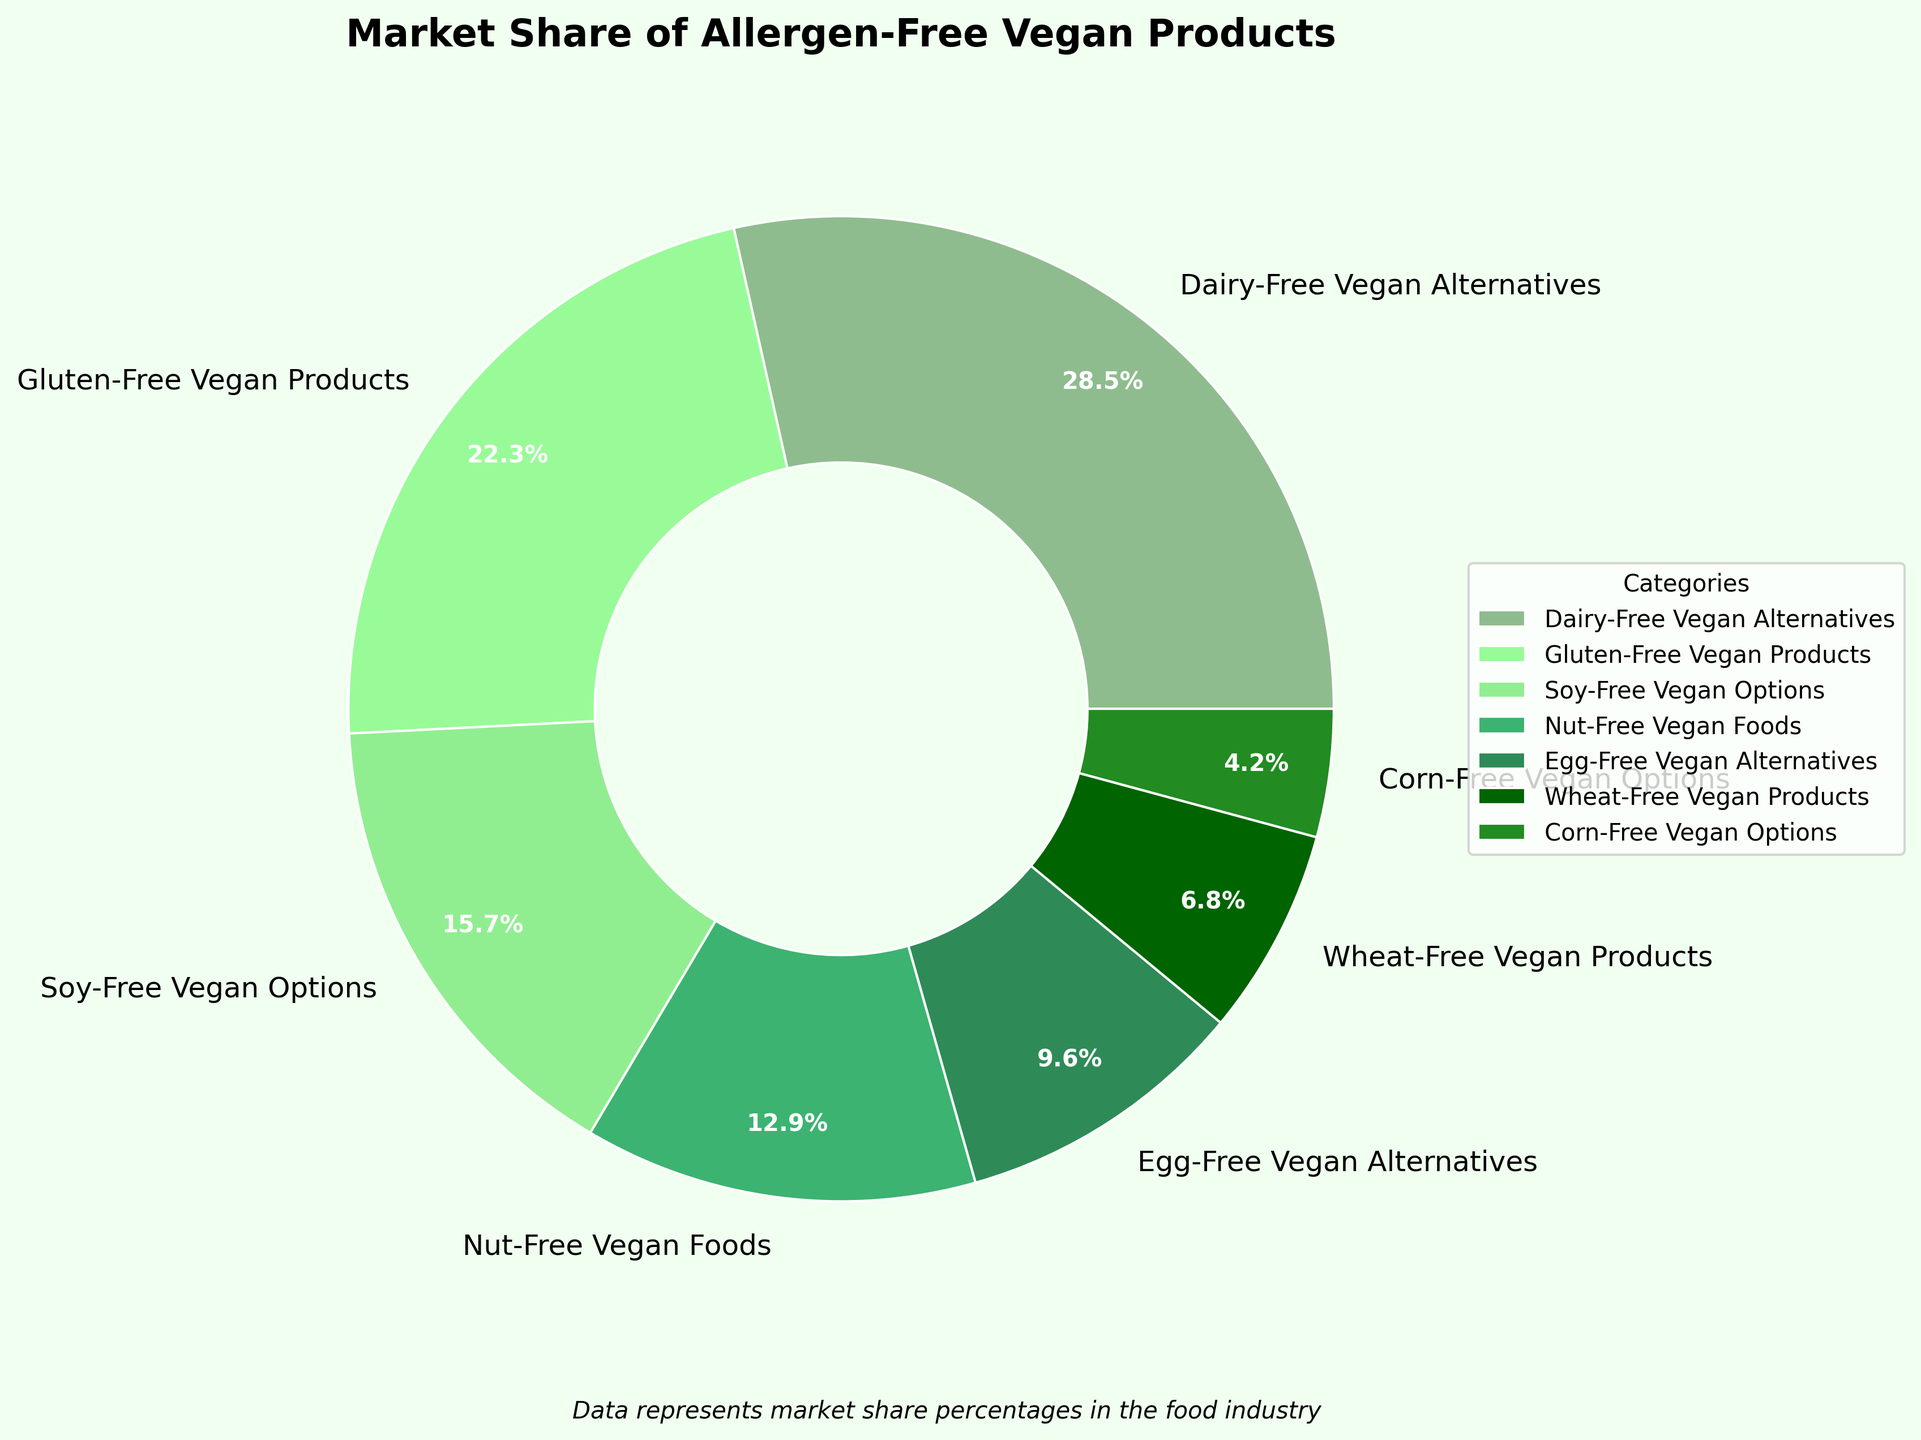Which category has the highest market share? The pie chart shows various categories with their corresponding market shares. The category with the highest percentage is visually identifiable as Dairy-Free Vegan Alternatives.
Answer: Dairy-Free Vegan Alternatives What is the combined market share of Nut-Free Vegan Foods and Egg-Free Vegan Alternatives? To find the combined market share, you need to add the market shares of Nut-Free Vegan Foods (12.9) and Egg-Free Vegan Alternatives (9.6). The sum of 12.9 and 9.6 is 22.5.
Answer: 22.5 Which category has a market share close to 22%? From the pie chart, the category that closely matches 22% is Gluten-Free Vegan Products, which has a market share of 22.3%.
Answer: Gluten-Free Vegan Products How does the market share of Soy-Free Vegan Options compare to that of Wheat-Free Vegan Products? The pie chart indicates that Soy-Free Vegan Options have a market share of 15.7%, whereas Wheat-Free Vegan Products have a smaller share of 6.8%. Therefore, Soy-Free Vegan Options have a higher market share.
Answer: Soy-Free Vegan Options have a higher market share What is the total market share of all categories excluding Dairy-Free Vegan Alternatives? Excluding Dairy-Free Vegan Alternatives, sum the market shares of all other categories: 22.3 (Gluten-Free Vegan Products) + 15.7 (Soy-Free Vegan Options) + 12.9 (Nut-Free Vegan Foods) + 9.6 (Egg-Free Vegan Alternatives) + 6.8 (Wheat-Free Vegan Products) + 4.2 (Corn-Free Vegan Options) = 71.5.
Answer: 71.5 Which category has the smallest market share, and what is its percentage? From the pie chart, Corn-Free Vegan Options has the smallest market share, which is shown as 4.2%.
Answer: Corn-Free Vegan Options, 4.2% By how much does the market share of Dairy-Free Vegan Alternatives exceed that of Nut-Free Vegan Foods? To determine the difference, subtract the market share of Nut-Free Vegan Foods (12.9) from Dairy-Free Vegan Alternatives (28.5). The difference is 28.5 - 12.9 = 15.6.
Answer: 15.6 Are there more categories with a market share greater than 10% or less than 10%? The categories with a market share greater than 10% are Dairy-Free Vegan Alternatives (28.5), Gluten-Free Vegan Products (22.3), Soy-Free Vegan Options (15.7), and Nut-Free Vegan Foods (12.9). Those with less than 10% are Egg-Free Vegan Alternatives (9.6), Wheat-Free Vegan Products (6.8), and Corn-Free Vegan Options (4.2). Thus, there are more categories with a market share greater than 10% (4) compared to those with less than 10% (3).
Answer: More categories have a market share greater than 10% What is the average market share of all categories? To calculate the average, sum the market shares of all categories and divide by the number of categories. (28.5 + 22.3 + 15.7 + 12.9 + 9.6 + 6.8 + 4.2) / 7 = 100 / 7 ≈ 14.29.
Answer: Approximately 14.29 If the market share of Gluten-Free Vegan Products increased by 5%, what would be the new combined market share of Gluten-Free and Dairy-Free Vegan Products? Increasing the market share of Gluten-Free Vegan Products by 5% yields 22.3 + 5 = 27.3. Adding this to the market share of Dairy-Free Vegan Alternatives gives 27.3 + 28.5 = 55.8.
Answer: 55.8 